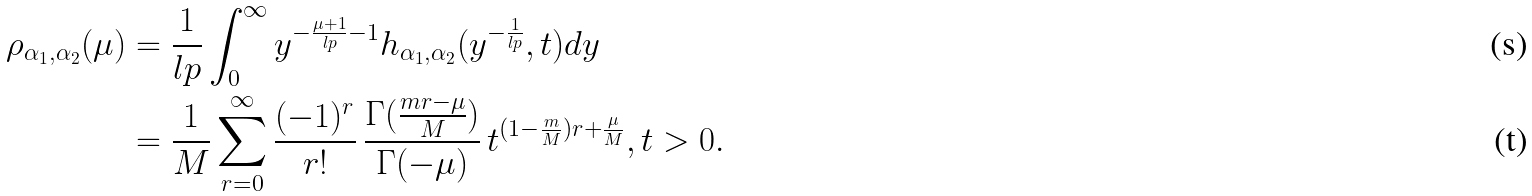Convert formula to latex. <formula><loc_0><loc_0><loc_500><loc_500>\rho _ { \alpha _ { 1 } , \alpha _ { 2 } } ( \mu ) & = \frac { 1 } { l p } \int _ { 0 } ^ { \infty } y ^ { - \frac { \mu + 1 } { l p } - 1 } h _ { \alpha _ { 1 } , \alpha _ { 2 } } ( y ^ { - \frac { 1 } { l p } } , t ) d y \\ & = \frac { 1 } { M } \sum _ { r = 0 } ^ { \infty } \frac { ( - 1 ) ^ { r } } { r ! } \, \frac { \Gamma ( \frac { m r - \mu } { M } ) } { \Gamma ( - \mu ) } \, t ^ { ( 1 - \frac { m } { M } ) r + \frac { \mu } { M } } , t > 0 .</formula> 